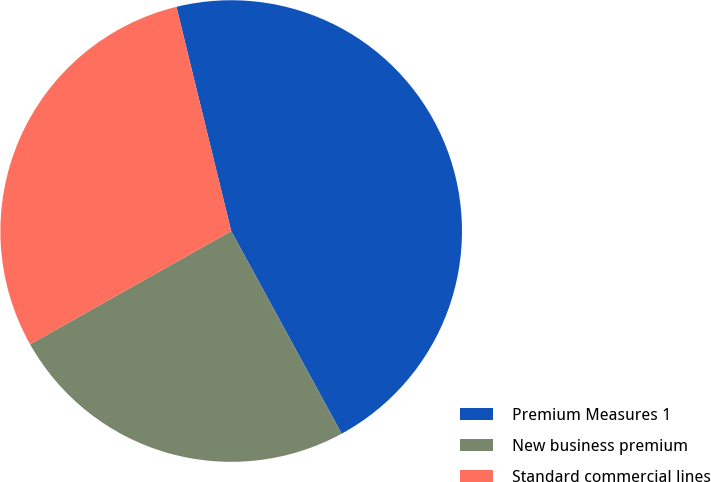Convert chart to OTSL. <chart><loc_0><loc_0><loc_500><loc_500><pie_chart><fcel>Premium Measures 1<fcel>New business premium<fcel>Standard commercial lines<nl><fcel>45.87%<fcel>24.78%<fcel>29.35%<nl></chart> 